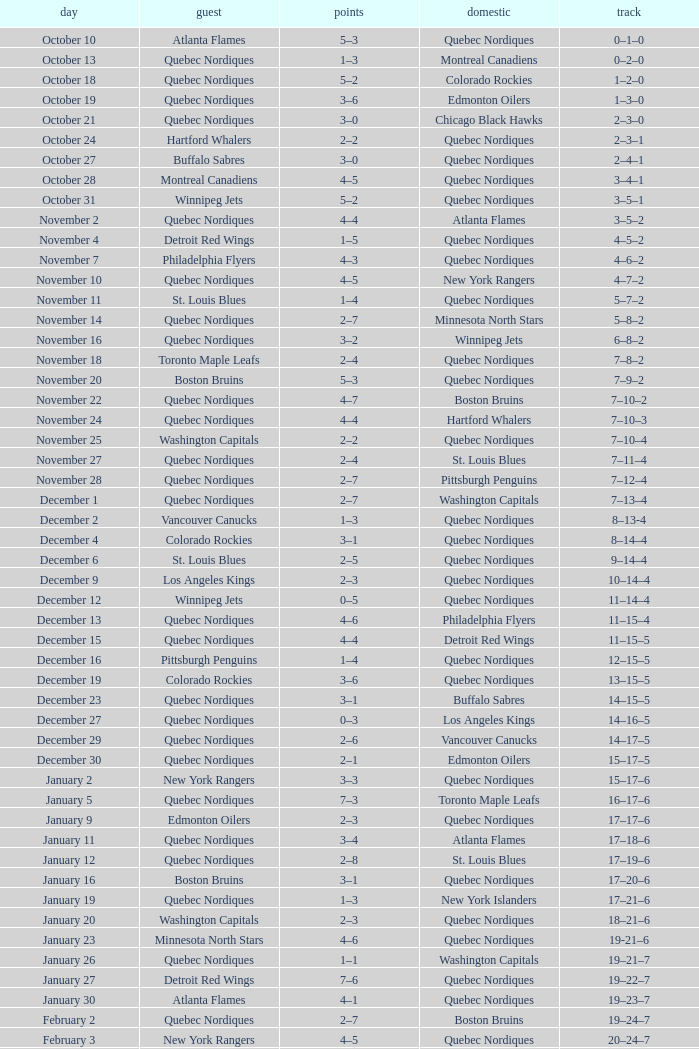Which Home has a Record of 16–17–6? Toronto Maple Leafs. 